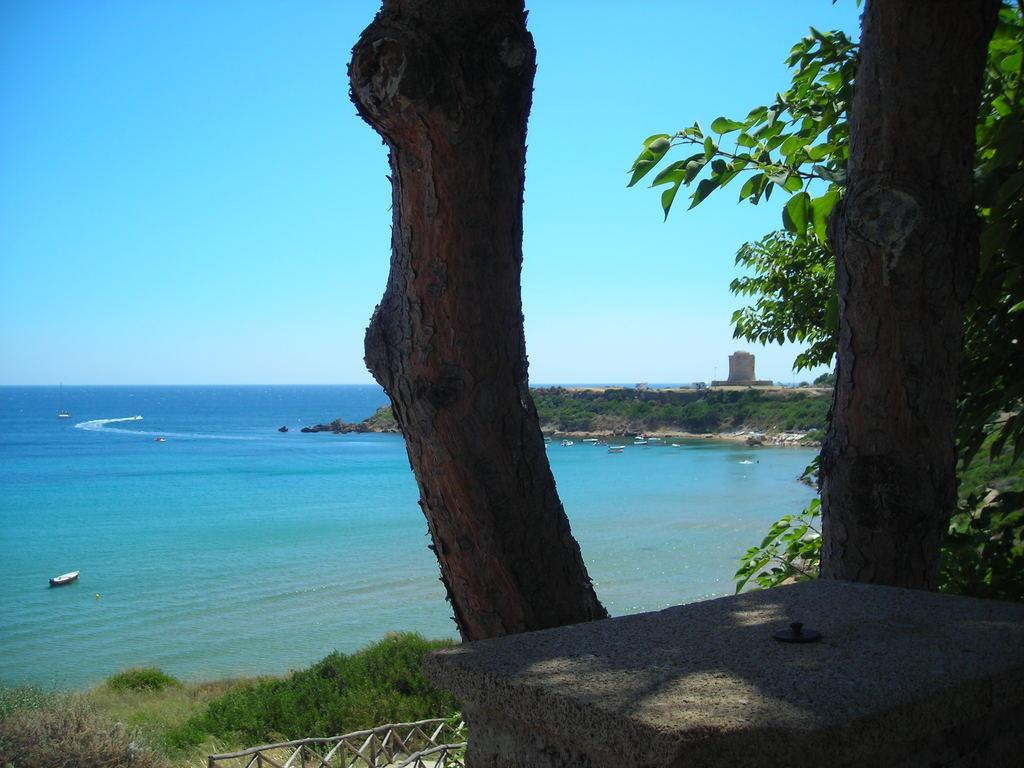What can be seen in the foreground of the image? There are tree trunks in the foreground of the image. What is visible in the background of the image? There are boats on the water in the background of the image. What type of natural environment is depicted in the image? There is greenery visible in the image. What type of table is present in the image? There is no table present in the image; it features tree trunks in the foreground and boats on the water in the background. What angle is the image taken from? The angle from which the image is taken is not mentioned in the provided facts, so it cannot be determined. 